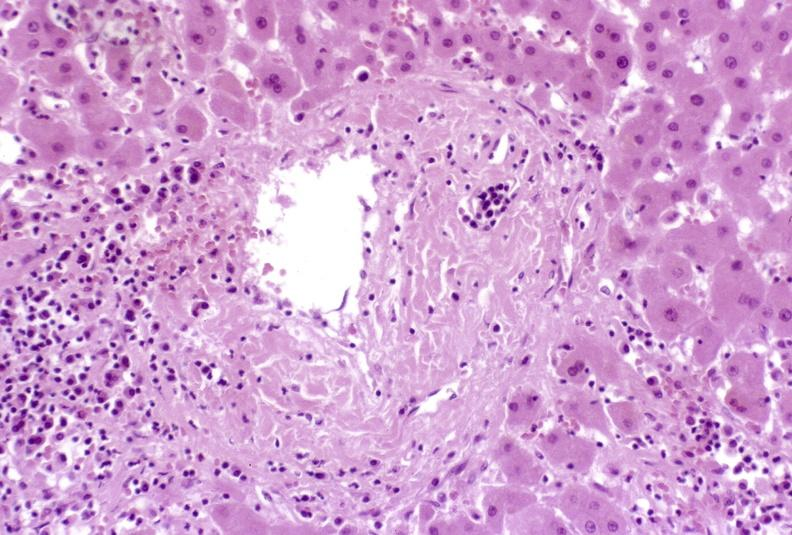s that present?
Answer the question using a single word or phrase. No 